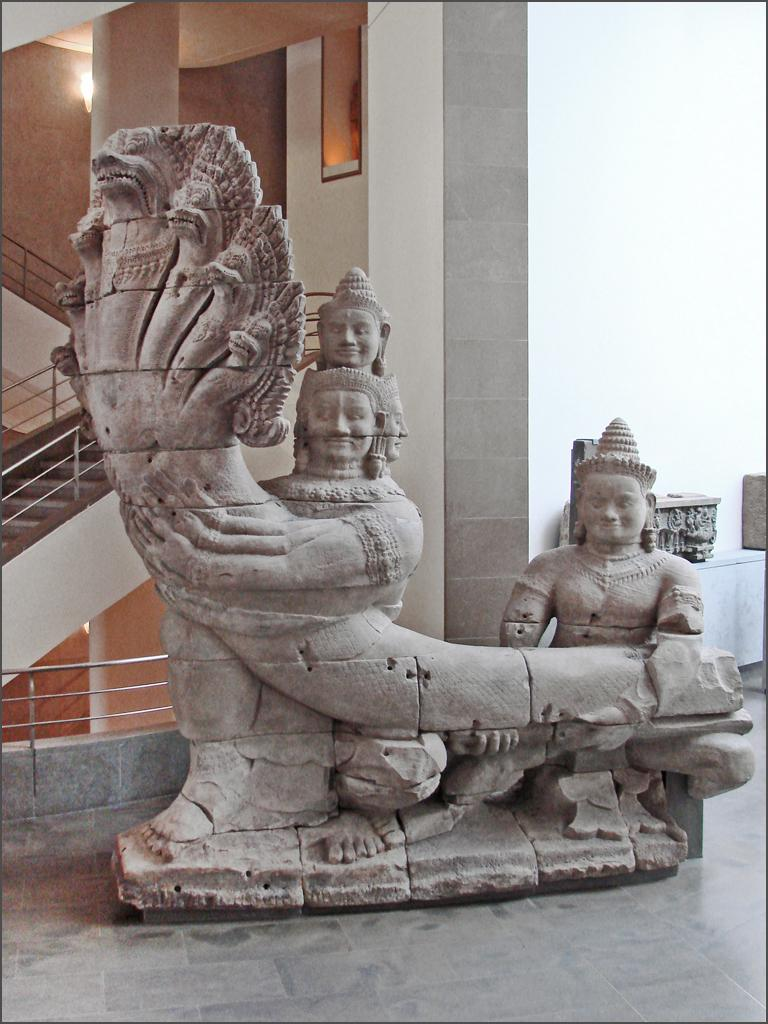What is the main subject of the image? There is a sculpture in the image. What is located behind the sculpture? There are stairs behind the sculpture. Where are the stairs situated? The stairs are located in a building. Can you tell me how many plants are growing in the lake near the sculpture? There is no lake or plants present in the image; it features a sculpture and stairs in a building. 